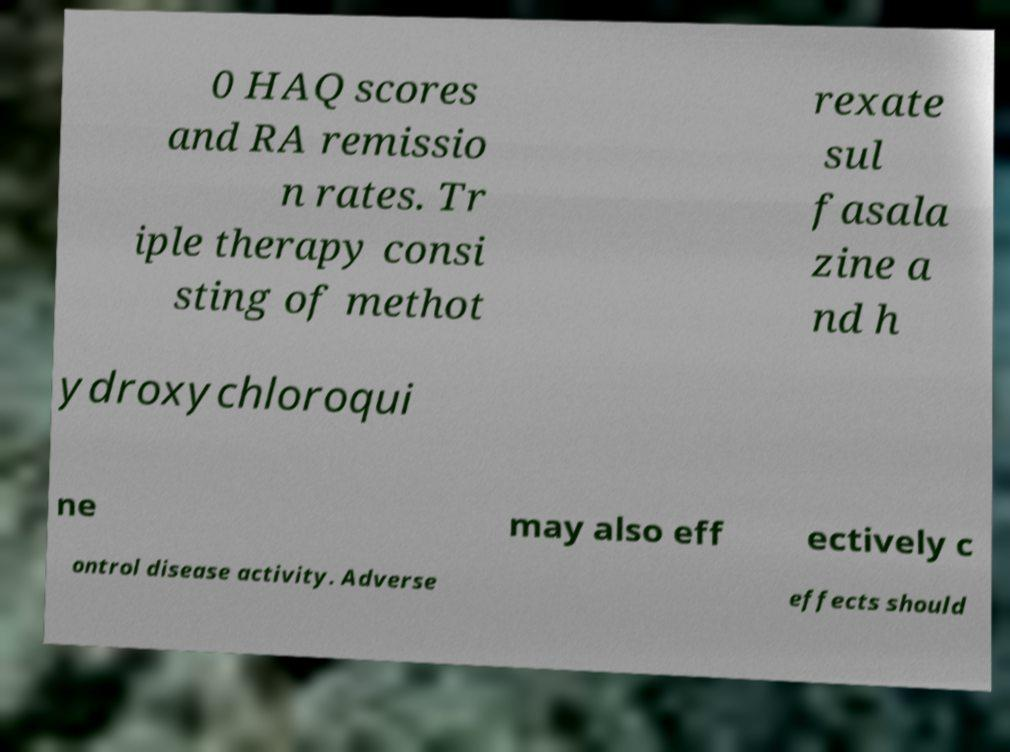Can you read and provide the text displayed in the image?This photo seems to have some interesting text. Can you extract and type it out for me? 0 HAQ scores and RA remissio n rates. Tr iple therapy consi sting of methot rexate sul fasala zine a nd h ydroxychloroqui ne may also eff ectively c ontrol disease activity. Adverse effects should 